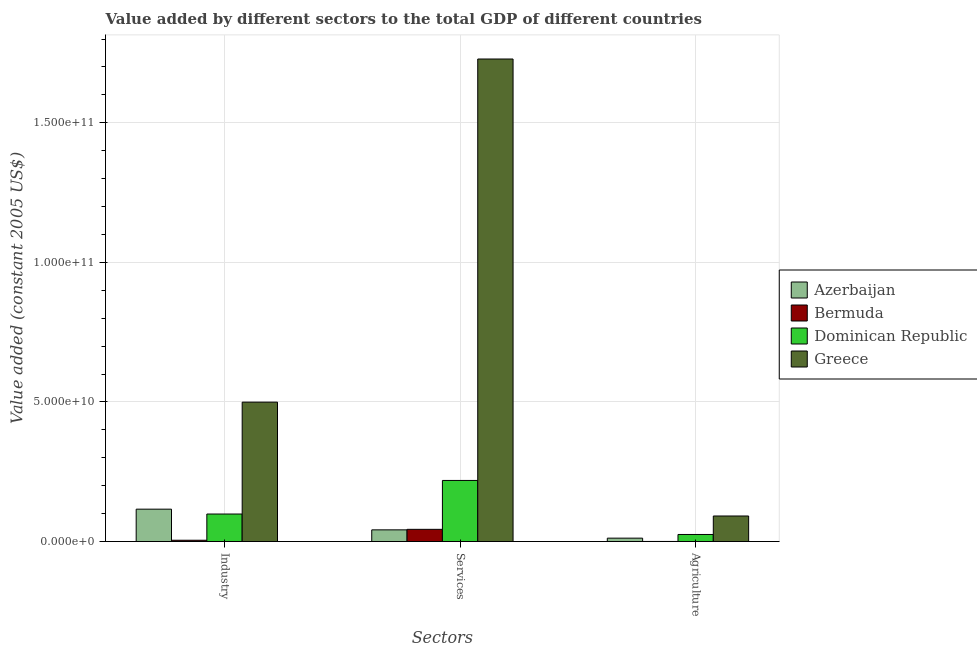How many bars are there on the 3rd tick from the right?
Offer a very short reply. 4. What is the label of the 3rd group of bars from the left?
Your answer should be compact. Agriculture. What is the value added by industrial sector in Azerbaijan?
Provide a succinct answer. 1.16e+1. Across all countries, what is the maximum value added by industrial sector?
Offer a very short reply. 4.99e+1. Across all countries, what is the minimum value added by agricultural sector?
Provide a short and direct response. 4.24e+07. In which country was the value added by services maximum?
Make the answer very short. Greece. In which country was the value added by industrial sector minimum?
Provide a succinct answer. Bermuda. What is the total value added by industrial sector in the graph?
Provide a short and direct response. 7.19e+1. What is the difference between the value added by services in Azerbaijan and that in Dominican Republic?
Keep it short and to the point. -1.77e+1. What is the difference between the value added by services in Greece and the value added by industrial sector in Dominican Republic?
Your answer should be very brief. 1.63e+11. What is the average value added by services per country?
Provide a succinct answer. 5.08e+1. What is the difference between the value added by industrial sector and value added by agricultural sector in Greece?
Your answer should be compact. 4.08e+1. What is the ratio of the value added by agricultural sector in Bermuda to that in Greece?
Provide a succinct answer. 0. Is the value added by industrial sector in Bermuda less than that in Greece?
Make the answer very short. Yes. Is the difference between the value added by agricultural sector in Greece and Azerbaijan greater than the difference between the value added by industrial sector in Greece and Azerbaijan?
Provide a short and direct response. No. What is the difference between the highest and the second highest value added by industrial sector?
Give a very brief answer. 3.83e+1. What is the difference between the highest and the lowest value added by agricultural sector?
Provide a succinct answer. 9.11e+09. In how many countries, is the value added by agricultural sector greater than the average value added by agricultural sector taken over all countries?
Provide a succinct answer. 1. Is the sum of the value added by services in Dominican Republic and Greece greater than the maximum value added by industrial sector across all countries?
Provide a short and direct response. Yes. What does the 1st bar from the left in Industry represents?
Ensure brevity in your answer.  Azerbaijan. Are all the bars in the graph horizontal?
Offer a terse response. No. How many countries are there in the graph?
Provide a succinct answer. 4. Does the graph contain any zero values?
Offer a terse response. No. How many legend labels are there?
Make the answer very short. 4. How are the legend labels stacked?
Ensure brevity in your answer.  Vertical. What is the title of the graph?
Ensure brevity in your answer.  Value added by different sectors to the total GDP of different countries. What is the label or title of the X-axis?
Provide a succinct answer. Sectors. What is the label or title of the Y-axis?
Offer a very short reply. Value added (constant 2005 US$). What is the Value added (constant 2005 US$) in Azerbaijan in Industry?
Give a very brief answer. 1.16e+1. What is the Value added (constant 2005 US$) in Bermuda in Industry?
Your response must be concise. 4.71e+08. What is the Value added (constant 2005 US$) of Dominican Republic in Industry?
Your answer should be compact. 9.86e+09. What is the Value added (constant 2005 US$) in Greece in Industry?
Provide a short and direct response. 4.99e+1. What is the Value added (constant 2005 US$) in Azerbaijan in Services?
Keep it short and to the point. 4.20e+09. What is the Value added (constant 2005 US$) of Bermuda in Services?
Give a very brief answer. 4.38e+09. What is the Value added (constant 2005 US$) in Dominican Republic in Services?
Keep it short and to the point. 2.19e+1. What is the Value added (constant 2005 US$) in Greece in Services?
Make the answer very short. 1.73e+11. What is the Value added (constant 2005 US$) of Azerbaijan in Agriculture?
Ensure brevity in your answer.  1.22e+09. What is the Value added (constant 2005 US$) of Bermuda in Agriculture?
Ensure brevity in your answer.  4.24e+07. What is the Value added (constant 2005 US$) in Dominican Republic in Agriculture?
Give a very brief answer. 2.54e+09. What is the Value added (constant 2005 US$) of Greece in Agriculture?
Offer a terse response. 9.16e+09. Across all Sectors, what is the maximum Value added (constant 2005 US$) of Azerbaijan?
Provide a short and direct response. 1.16e+1. Across all Sectors, what is the maximum Value added (constant 2005 US$) in Bermuda?
Your answer should be compact. 4.38e+09. Across all Sectors, what is the maximum Value added (constant 2005 US$) in Dominican Republic?
Give a very brief answer. 2.19e+1. Across all Sectors, what is the maximum Value added (constant 2005 US$) in Greece?
Your answer should be very brief. 1.73e+11. Across all Sectors, what is the minimum Value added (constant 2005 US$) in Azerbaijan?
Provide a succinct answer. 1.22e+09. Across all Sectors, what is the minimum Value added (constant 2005 US$) of Bermuda?
Give a very brief answer. 4.24e+07. Across all Sectors, what is the minimum Value added (constant 2005 US$) in Dominican Republic?
Offer a terse response. 2.54e+09. Across all Sectors, what is the minimum Value added (constant 2005 US$) in Greece?
Keep it short and to the point. 9.16e+09. What is the total Value added (constant 2005 US$) of Azerbaijan in the graph?
Your response must be concise. 1.70e+1. What is the total Value added (constant 2005 US$) in Bermuda in the graph?
Your answer should be very brief. 4.89e+09. What is the total Value added (constant 2005 US$) in Dominican Republic in the graph?
Ensure brevity in your answer.  3.43e+1. What is the total Value added (constant 2005 US$) of Greece in the graph?
Make the answer very short. 2.32e+11. What is the difference between the Value added (constant 2005 US$) in Azerbaijan in Industry and that in Services?
Your response must be concise. 7.41e+09. What is the difference between the Value added (constant 2005 US$) in Bermuda in Industry and that in Services?
Your answer should be compact. -3.91e+09. What is the difference between the Value added (constant 2005 US$) of Dominican Republic in Industry and that in Services?
Provide a succinct answer. -1.20e+1. What is the difference between the Value added (constant 2005 US$) in Greece in Industry and that in Services?
Provide a short and direct response. -1.23e+11. What is the difference between the Value added (constant 2005 US$) of Azerbaijan in Industry and that in Agriculture?
Provide a short and direct response. 1.04e+1. What is the difference between the Value added (constant 2005 US$) in Bermuda in Industry and that in Agriculture?
Your answer should be compact. 4.29e+08. What is the difference between the Value added (constant 2005 US$) of Dominican Republic in Industry and that in Agriculture?
Your answer should be compact. 7.33e+09. What is the difference between the Value added (constant 2005 US$) of Greece in Industry and that in Agriculture?
Offer a terse response. 4.08e+1. What is the difference between the Value added (constant 2005 US$) in Azerbaijan in Services and that in Agriculture?
Your answer should be very brief. 2.97e+09. What is the difference between the Value added (constant 2005 US$) in Bermuda in Services and that in Agriculture?
Your answer should be compact. 4.34e+09. What is the difference between the Value added (constant 2005 US$) in Dominican Republic in Services and that in Agriculture?
Ensure brevity in your answer.  1.94e+1. What is the difference between the Value added (constant 2005 US$) in Greece in Services and that in Agriculture?
Your response must be concise. 1.64e+11. What is the difference between the Value added (constant 2005 US$) in Azerbaijan in Industry and the Value added (constant 2005 US$) in Bermuda in Services?
Offer a terse response. 7.23e+09. What is the difference between the Value added (constant 2005 US$) of Azerbaijan in Industry and the Value added (constant 2005 US$) of Dominican Republic in Services?
Your response must be concise. -1.03e+1. What is the difference between the Value added (constant 2005 US$) in Azerbaijan in Industry and the Value added (constant 2005 US$) in Greece in Services?
Provide a succinct answer. -1.61e+11. What is the difference between the Value added (constant 2005 US$) in Bermuda in Industry and the Value added (constant 2005 US$) in Dominican Republic in Services?
Your answer should be compact. -2.14e+1. What is the difference between the Value added (constant 2005 US$) in Bermuda in Industry and the Value added (constant 2005 US$) in Greece in Services?
Offer a terse response. -1.72e+11. What is the difference between the Value added (constant 2005 US$) in Dominican Republic in Industry and the Value added (constant 2005 US$) in Greece in Services?
Keep it short and to the point. -1.63e+11. What is the difference between the Value added (constant 2005 US$) of Azerbaijan in Industry and the Value added (constant 2005 US$) of Bermuda in Agriculture?
Your response must be concise. 1.16e+1. What is the difference between the Value added (constant 2005 US$) in Azerbaijan in Industry and the Value added (constant 2005 US$) in Dominican Republic in Agriculture?
Your response must be concise. 9.07e+09. What is the difference between the Value added (constant 2005 US$) of Azerbaijan in Industry and the Value added (constant 2005 US$) of Greece in Agriculture?
Make the answer very short. 2.45e+09. What is the difference between the Value added (constant 2005 US$) in Bermuda in Industry and the Value added (constant 2005 US$) in Dominican Republic in Agriculture?
Provide a short and direct response. -2.07e+09. What is the difference between the Value added (constant 2005 US$) of Bermuda in Industry and the Value added (constant 2005 US$) of Greece in Agriculture?
Make the answer very short. -8.69e+09. What is the difference between the Value added (constant 2005 US$) of Dominican Republic in Industry and the Value added (constant 2005 US$) of Greece in Agriculture?
Keep it short and to the point. 7.07e+08. What is the difference between the Value added (constant 2005 US$) of Azerbaijan in Services and the Value added (constant 2005 US$) of Bermuda in Agriculture?
Provide a succinct answer. 4.15e+09. What is the difference between the Value added (constant 2005 US$) in Azerbaijan in Services and the Value added (constant 2005 US$) in Dominican Republic in Agriculture?
Your answer should be very brief. 1.66e+09. What is the difference between the Value added (constant 2005 US$) in Azerbaijan in Services and the Value added (constant 2005 US$) in Greece in Agriculture?
Your answer should be very brief. -4.96e+09. What is the difference between the Value added (constant 2005 US$) in Bermuda in Services and the Value added (constant 2005 US$) in Dominican Republic in Agriculture?
Your response must be concise. 1.84e+09. What is the difference between the Value added (constant 2005 US$) in Bermuda in Services and the Value added (constant 2005 US$) in Greece in Agriculture?
Your answer should be very brief. -4.78e+09. What is the difference between the Value added (constant 2005 US$) in Dominican Republic in Services and the Value added (constant 2005 US$) in Greece in Agriculture?
Your answer should be very brief. 1.27e+1. What is the average Value added (constant 2005 US$) in Azerbaijan per Sectors?
Keep it short and to the point. 5.67e+09. What is the average Value added (constant 2005 US$) of Bermuda per Sectors?
Provide a short and direct response. 1.63e+09. What is the average Value added (constant 2005 US$) in Dominican Republic per Sectors?
Offer a very short reply. 1.14e+1. What is the average Value added (constant 2005 US$) of Greece per Sectors?
Offer a terse response. 7.73e+1. What is the difference between the Value added (constant 2005 US$) in Azerbaijan and Value added (constant 2005 US$) in Bermuda in Industry?
Keep it short and to the point. 1.11e+1. What is the difference between the Value added (constant 2005 US$) in Azerbaijan and Value added (constant 2005 US$) in Dominican Republic in Industry?
Give a very brief answer. 1.74e+09. What is the difference between the Value added (constant 2005 US$) in Azerbaijan and Value added (constant 2005 US$) in Greece in Industry?
Give a very brief answer. -3.83e+1. What is the difference between the Value added (constant 2005 US$) in Bermuda and Value added (constant 2005 US$) in Dominican Republic in Industry?
Offer a terse response. -9.39e+09. What is the difference between the Value added (constant 2005 US$) of Bermuda and Value added (constant 2005 US$) of Greece in Industry?
Your response must be concise. -4.95e+1. What is the difference between the Value added (constant 2005 US$) of Dominican Republic and Value added (constant 2005 US$) of Greece in Industry?
Keep it short and to the point. -4.01e+1. What is the difference between the Value added (constant 2005 US$) of Azerbaijan and Value added (constant 2005 US$) of Bermuda in Services?
Give a very brief answer. -1.83e+08. What is the difference between the Value added (constant 2005 US$) of Azerbaijan and Value added (constant 2005 US$) of Dominican Republic in Services?
Make the answer very short. -1.77e+1. What is the difference between the Value added (constant 2005 US$) in Azerbaijan and Value added (constant 2005 US$) in Greece in Services?
Give a very brief answer. -1.69e+11. What is the difference between the Value added (constant 2005 US$) in Bermuda and Value added (constant 2005 US$) in Dominican Republic in Services?
Give a very brief answer. -1.75e+1. What is the difference between the Value added (constant 2005 US$) in Bermuda and Value added (constant 2005 US$) in Greece in Services?
Offer a terse response. -1.68e+11. What is the difference between the Value added (constant 2005 US$) in Dominican Republic and Value added (constant 2005 US$) in Greece in Services?
Offer a very short reply. -1.51e+11. What is the difference between the Value added (constant 2005 US$) in Azerbaijan and Value added (constant 2005 US$) in Bermuda in Agriculture?
Offer a very short reply. 1.18e+09. What is the difference between the Value added (constant 2005 US$) in Azerbaijan and Value added (constant 2005 US$) in Dominican Republic in Agriculture?
Your answer should be compact. -1.31e+09. What is the difference between the Value added (constant 2005 US$) of Azerbaijan and Value added (constant 2005 US$) of Greece in Agriculture?
Your response must be concise. -7.93e+09. What is the difference between the Value added (constant 2005 US$) of Bermuda and Value added (constant 2005 US$) of Dominican Republic in Agriculture?
Your answer should be very brief. -2.49e+09. What is the difference between the Value added (constant 2005 US$) in Bermuda and Value added (constant 2005 US$) in Greece in Agriculture?
Provide a succinct answer. -9.11e+09. What is the difference between the Value added (constant 2005 US$) of Dominican Republic and Value added (constant 2005 US$) of Greece in Agriculture?
Ensure brevity in your answer.  -6.62e+09. What is the ratio of the Value added (constant 2005 US$) in Azerbaijan in Industry to that in Services?
Offer a terse response. 2.77. What is the ratio of the Value added (constant 2005 US$) in Bermuda in Industry to that in Services?
Your answer should be very brief. 0.11. What is the ratio of the Value added (constant 2005 US$) in Dominican Republic in Industry to that in Services?
Ensure brevity in your answer.  0.45. What is the ratio of the Value added (constant 2005 US$) of Greece in Industry to that in Services?
Ensure brevity in your answer.  0.29. What is the ratio of the Value added (constant 2005 US$) in Azerbaijan in Industry to that in Agriculture?
Offer a terse response. 9.49. What is the ratio of the Value added (constant 2005 US$) of Bermuda in Industry to that in Agriculture?
Make the answer very short. 11.1. What is the ratio of the Value added (constant 2005 US$) of Dominican Republic in Industry to that in Agriculture?
Offer a very short reply. 3.89. What is the ratio of the Value added (constant 2005 US$) of Greece in Industry to that in Agriculture?
Offer a terse response. 5.45. What is the ratio of the Value added (constant 2005 US$) of Azerbaijan in Services to that in Agriculture?
Your answer should be compact. 3.43. What is the ratio of the Value added (constant 2005 US$) of Bermuda in Services to that in Agriculture?
Keep it short and to the point. 103.18. What is the ratio of the Value added (constant 2005 US$) of Dominican Republic in Services to that in Agriculture?
Ensure brevity in your answer.  8.63. What is the ratio of the Value added (constant 2005 US$) of Greece in Services to that in Agriculture?
Make the answer very short. 18.88. What is the difference between the highest and the second highest Value added (constant 2005 US$) of Azerbaijan?
Ensure brevity in your answer.  7.41e+09. What is the difference between the highest and the second highest Value added (constant 2005 US$) in Bermuda?
Offer a very short reply. 3.91e+09. What is the difference between the highest and the second highest Value added (constant 2005 US$) in Dominican Republic?
Keep it short and to the point. 1.20e+1. What is the difference between the highest and the second highest Value added (constant 2005 US$) in Greece?
Ensure brevity in your answer.  1.23e+11. What is the difference between the highest and the lowest Value added (constant 2005 US$) of Azerbaijan?
Provide a short and direct response. 1.04e+1. What is the difference between the highest and the lowest Value added (constant 2005 US$) of Bermuda?
Give a very brief answer. 4.34e+09. What is the difference between the highest and the lowest Value added (constant 2005 US$) of Dominican Republic?
Provide a succinct answer. 1.94e+1. What is the difference between the highest and the lowest Value added (constant 2005 US$) in Greece?
Give a very brief answer. 1.64e+11. 